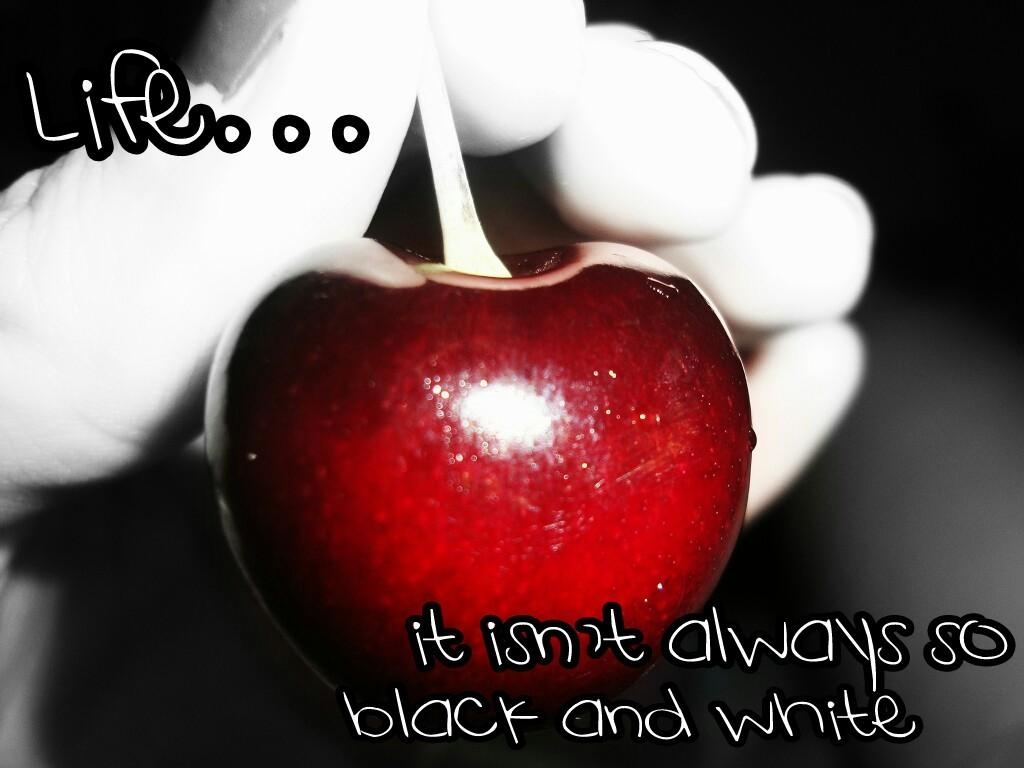What type of fruit is present in the image? There is an apple in the image. What else can be seen in the image besides the apple? There are words written in the image. How many mice are sitting on the branch in the image? There is no branch or mice present in the image. What type of sound can be heard coming from the apple in the image? The apple is a fruit and does not produce sound, so it cannot be heard making any sound. 